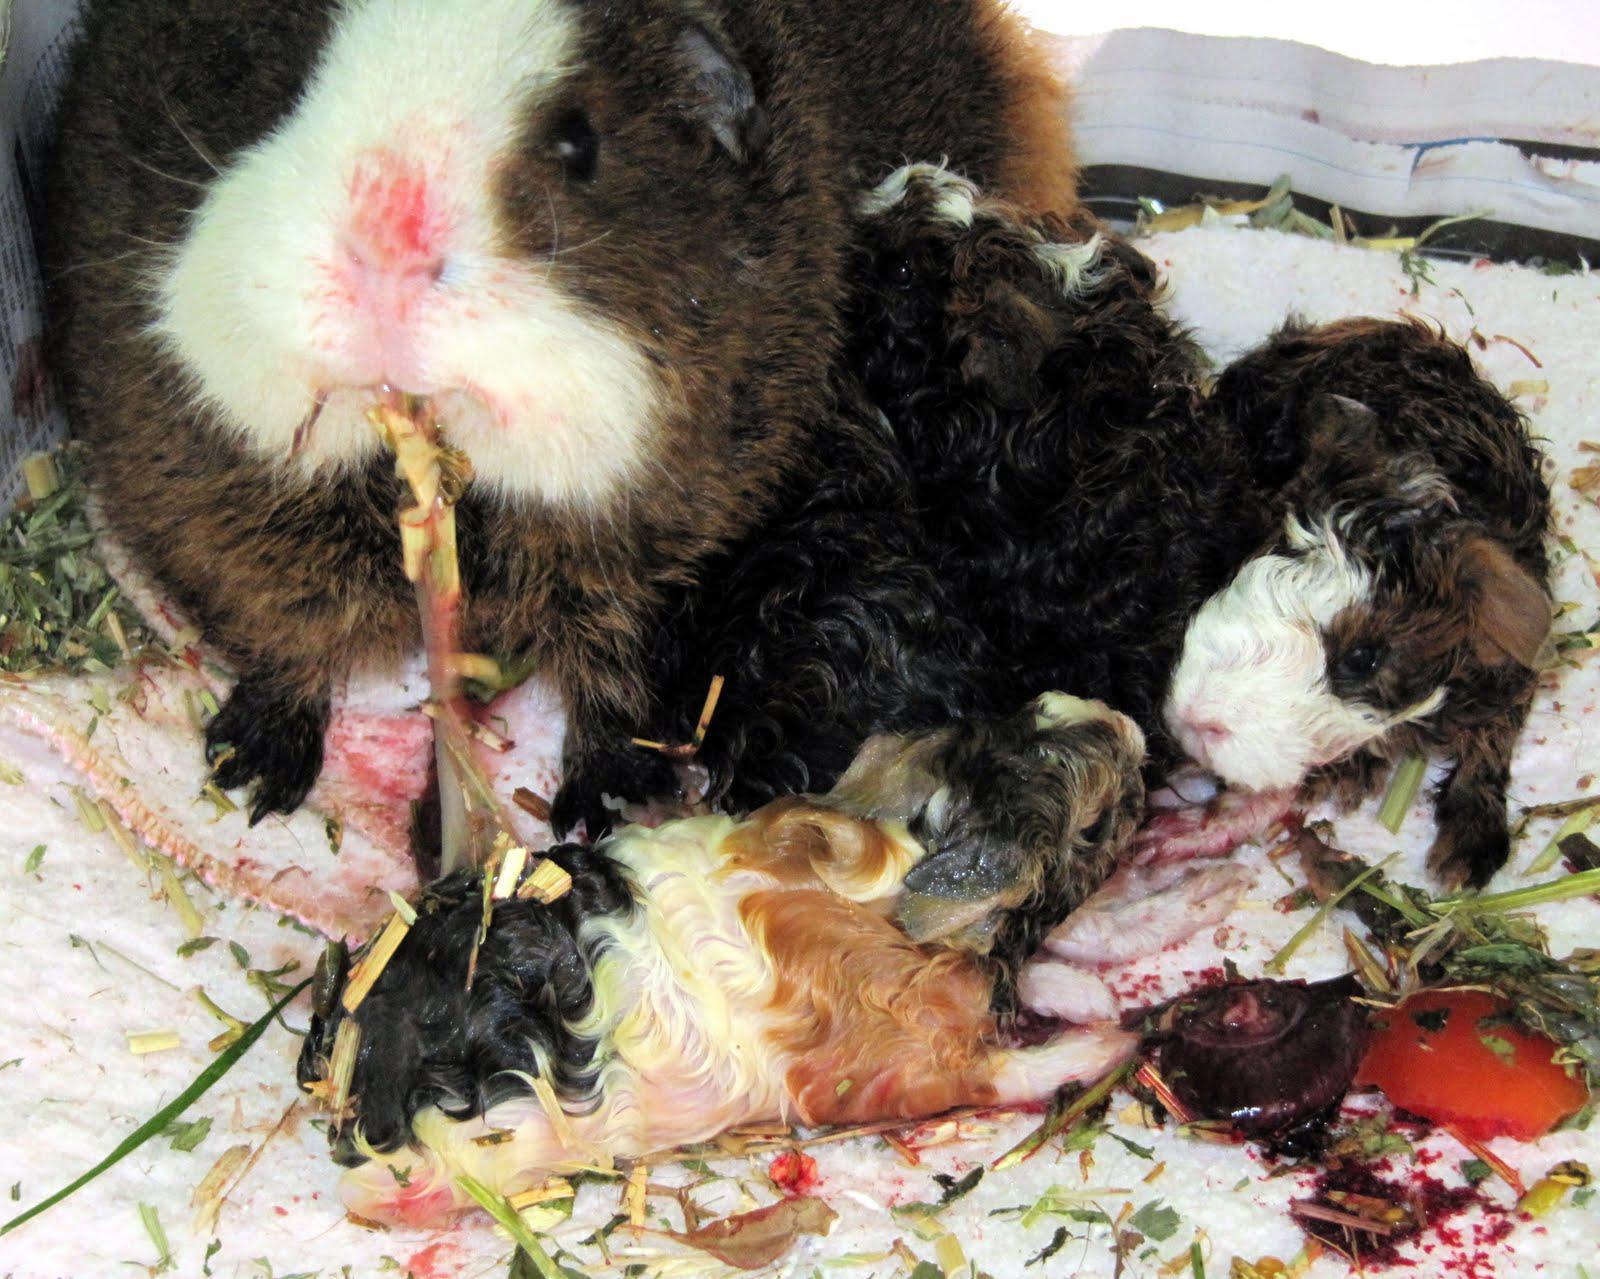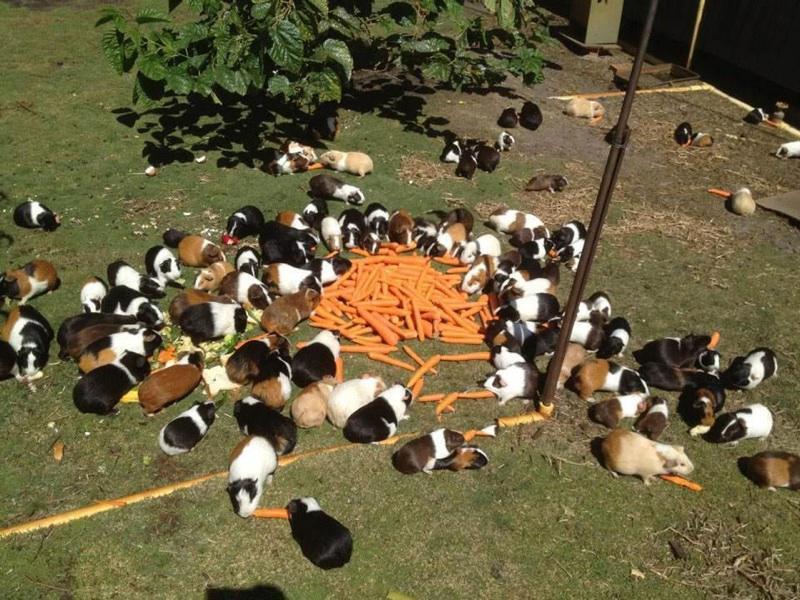The first image is the image on the left, the second image is the image on the right. Examine the images to the left and right. Is the description "An image shows multiple guinea pigs around a bowl of food." accurate? Answer yes or no. No. The first image is the image on the left, the second image is the image on the right. Considering the images on both sides, is "Guinea pics are eating green hay." valid? Answer yes or no. No. 